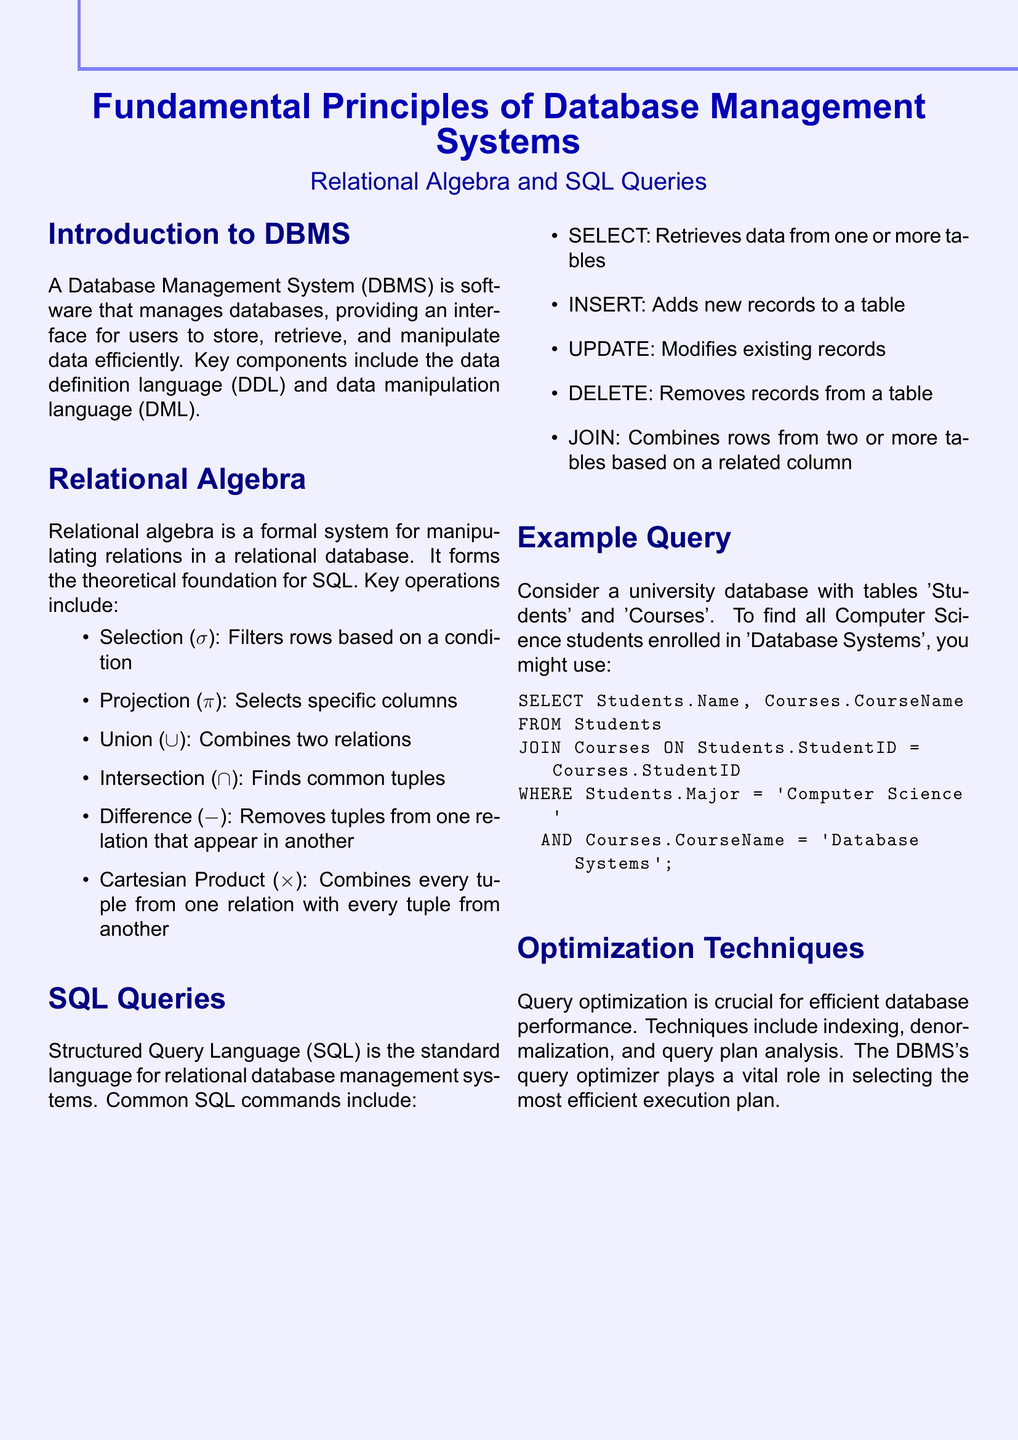What is the purpose of a Database Management System? A Database Management System (DBMS) manages databases, providing an interface for users to store, retrieve, and manipulate data efficiently.
Answer: managing databases What operation does the selection symbol represent in relational algebra? The selection symbol (σ) represents the operation that filters rows based on a condition.
Answer: filters rows Which SQL command adds new records to a table? The SQL command INSERT is used to add new records to a table.
Answer: INSERT How many key operations are listed in the relational algebra section? The document lists six key operations in relational algebra.
Answer: six What is the purpose of query optimization in database management? Query optimization is crucial for efficient database performance.
Answer: efficient performance What is the theoretical foundation for SQL? Relational algebra forms the theoretical foundation for SQL.
Answer: relational algebra In the example query, which major are the students enrolled in? The students in the example query are majoring in Computer Science.
Answer: Computer Science What technique is mentioned for improving database performance? Indexing is mentioned as a technique for improving database performance.
Answer: indexing 